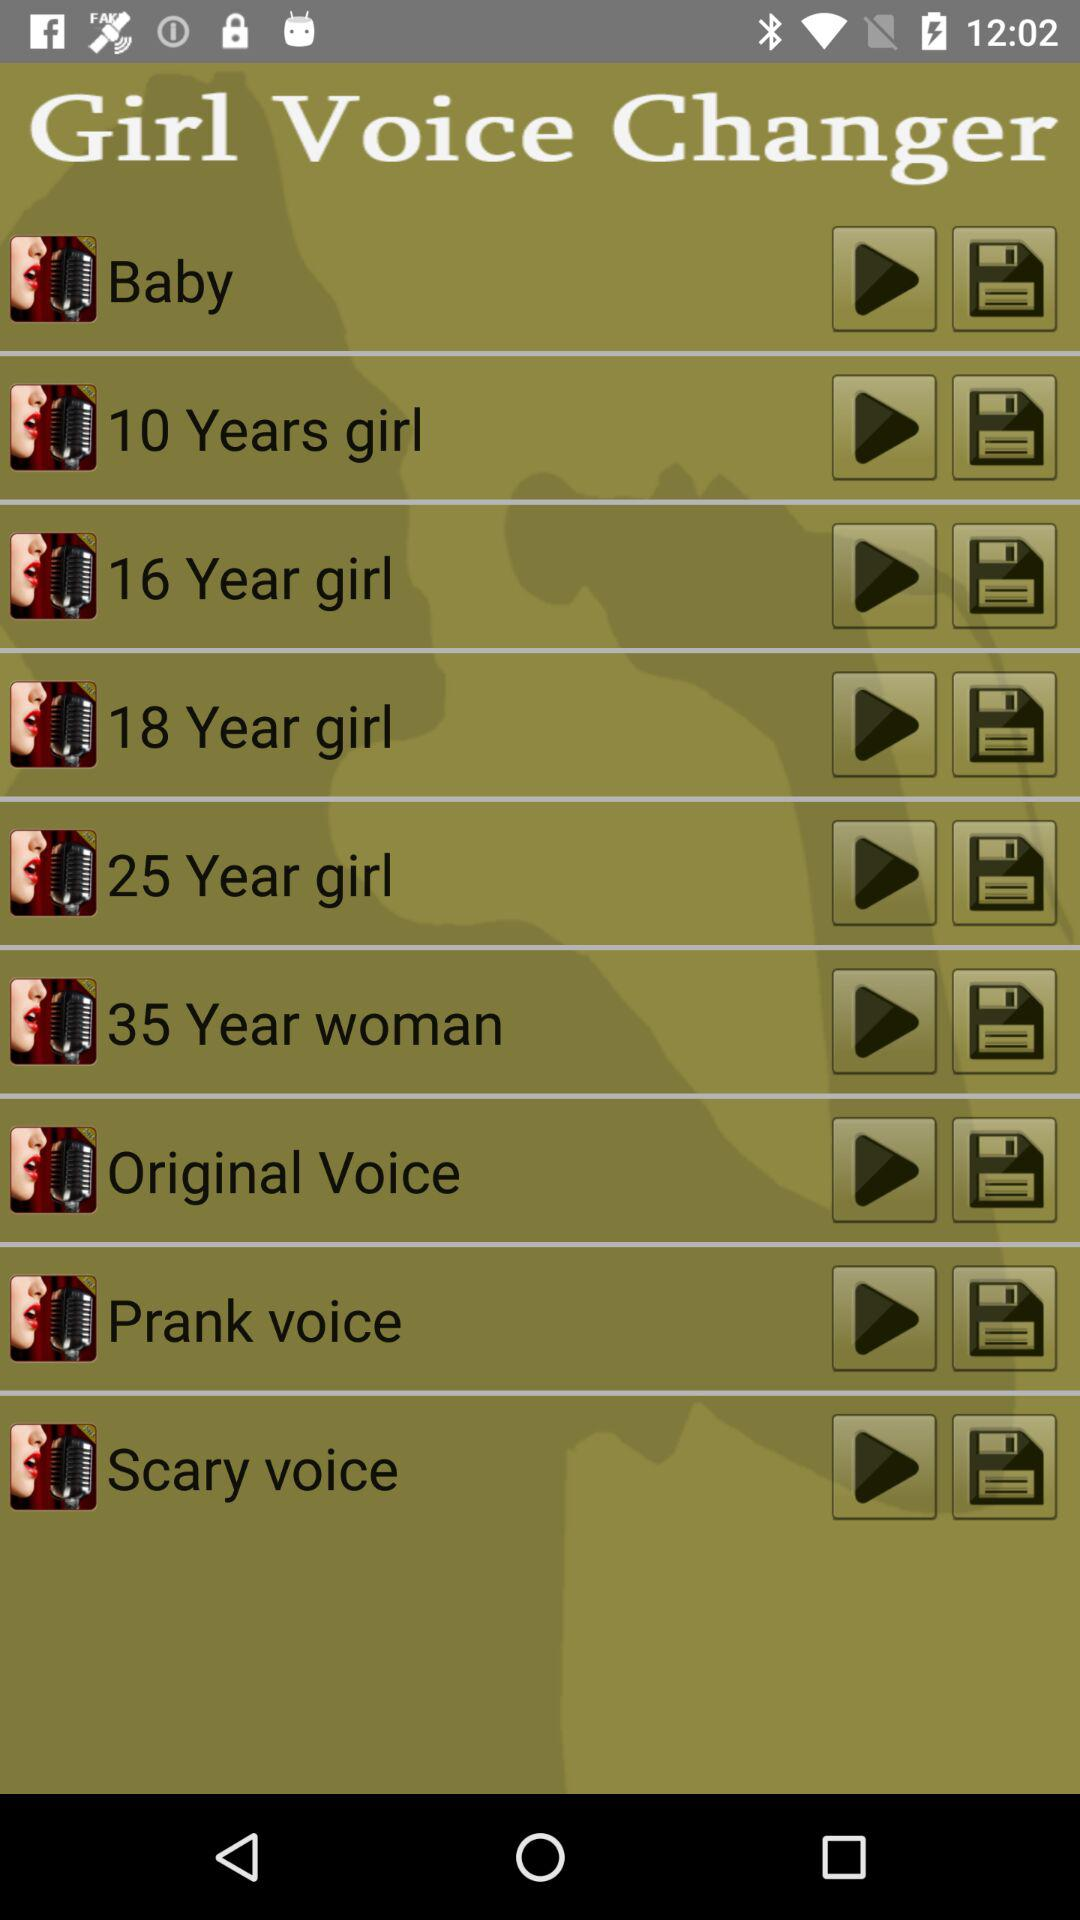What is the application name? The application name is "Girl Voice Changer". 